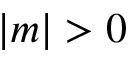<formula> <loc_0><loc_0><loc_500><loc_500>| m | > 0</formula> 